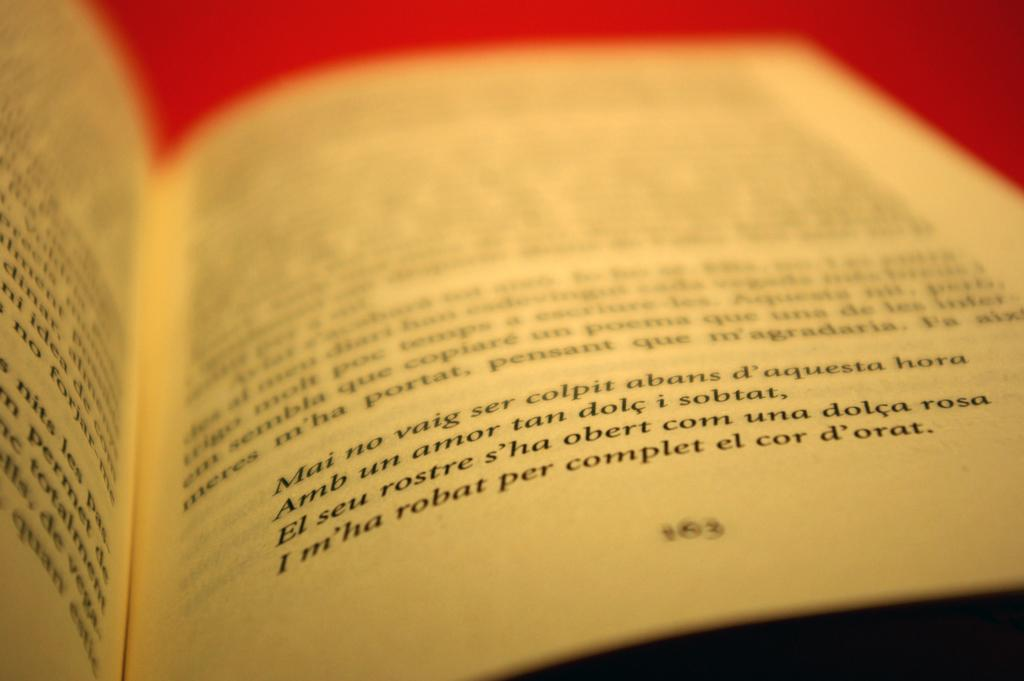<image>
Give a short and clear explanation of the subsequent image. A book is open to page 163 and discusses Mai no vaig. 